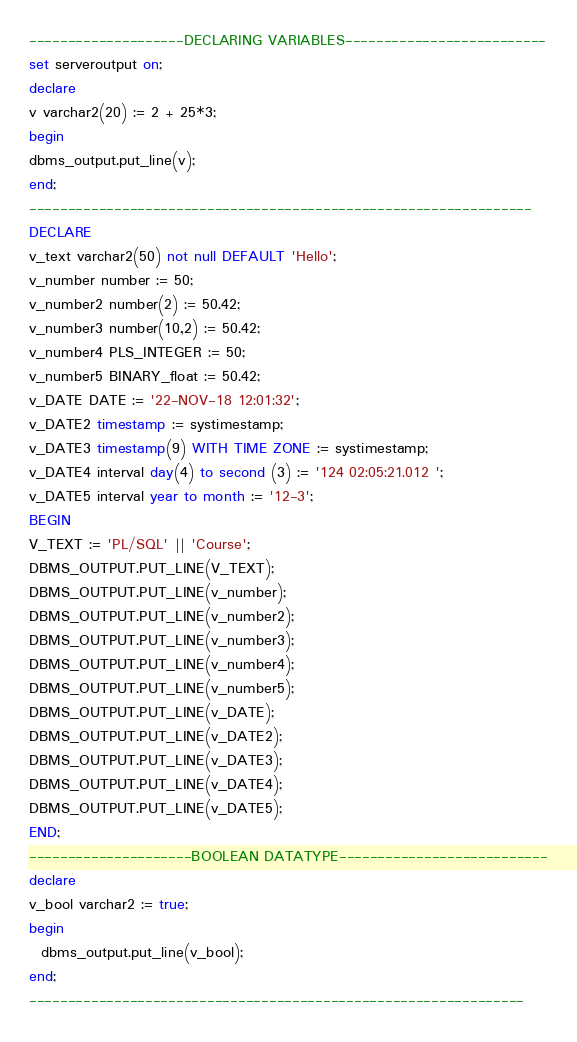<code> <loc_0><loc_0><loc_500><loc_500><_SQL_>--------------------DECLARING VARIABLES--------------------------
set serveroutput on;
declare 
v varchar2(20) := 2 + 25*3;
begin
dbms_output.put_line(v);
end;
-----------------------------------------------------------------
DECLARE 
v_text varchar2(50) not null DEFAULT 'Hello';
v_number number := 50;
v_number2 number(2) := 50.42;
v_number3 number(10,2) := 50.42;
v_number4 PLS_INTEGER := 50;
v_number5 BINARY_float := 50.42;
v_DATE DATE := '22-NOV-18 12:01:32';
v_DATE2 timestamp := systimestamp;
v_DATE3 timestamp(9) WITH TIME ZONE := systimestamp;
v_DATE4 interval day(4) to second (3) := '124 02:05:21.012 ';
v_DATE5 interval year to month := '12-3';
BEGIN
V_TEXT := 'PL/SQL' || 'Course';
DBMS_OUTPUT.PUT_LINE(V_TEXT);
DBMS_OUTPUT.PUT_LINE(v_number);
DBMS_OUTPUT.PUT_LINE(v_number2);
DBMS_OUTPUT.PUT_LINE(v_number3);
DBMS_OUTPUT.PUT_LINE(v_number4);
DBMS_OUTPUT.PUT_LINE(v_number5);
DBMS_OUTPUT.PUT_LINE(v_DATE);
DBMS_OUTPUT.PUT_LINE(v_DATE2);
DBMS_OUTPUT.PUT_LINE(v_DATE3);
DBMS_OUTPUT.PUT_LINE(v_DATE4);
DBMS_OUTPUT.PUT_LINE(v_DATE5);
END;
---------------------BOOLEAN DATATYPE---------------------------
declare
v_bool varchar2 := true;
begin
  dbms_output.put_line(v_bool);
end;
----------------------------------------------------------------</code> 